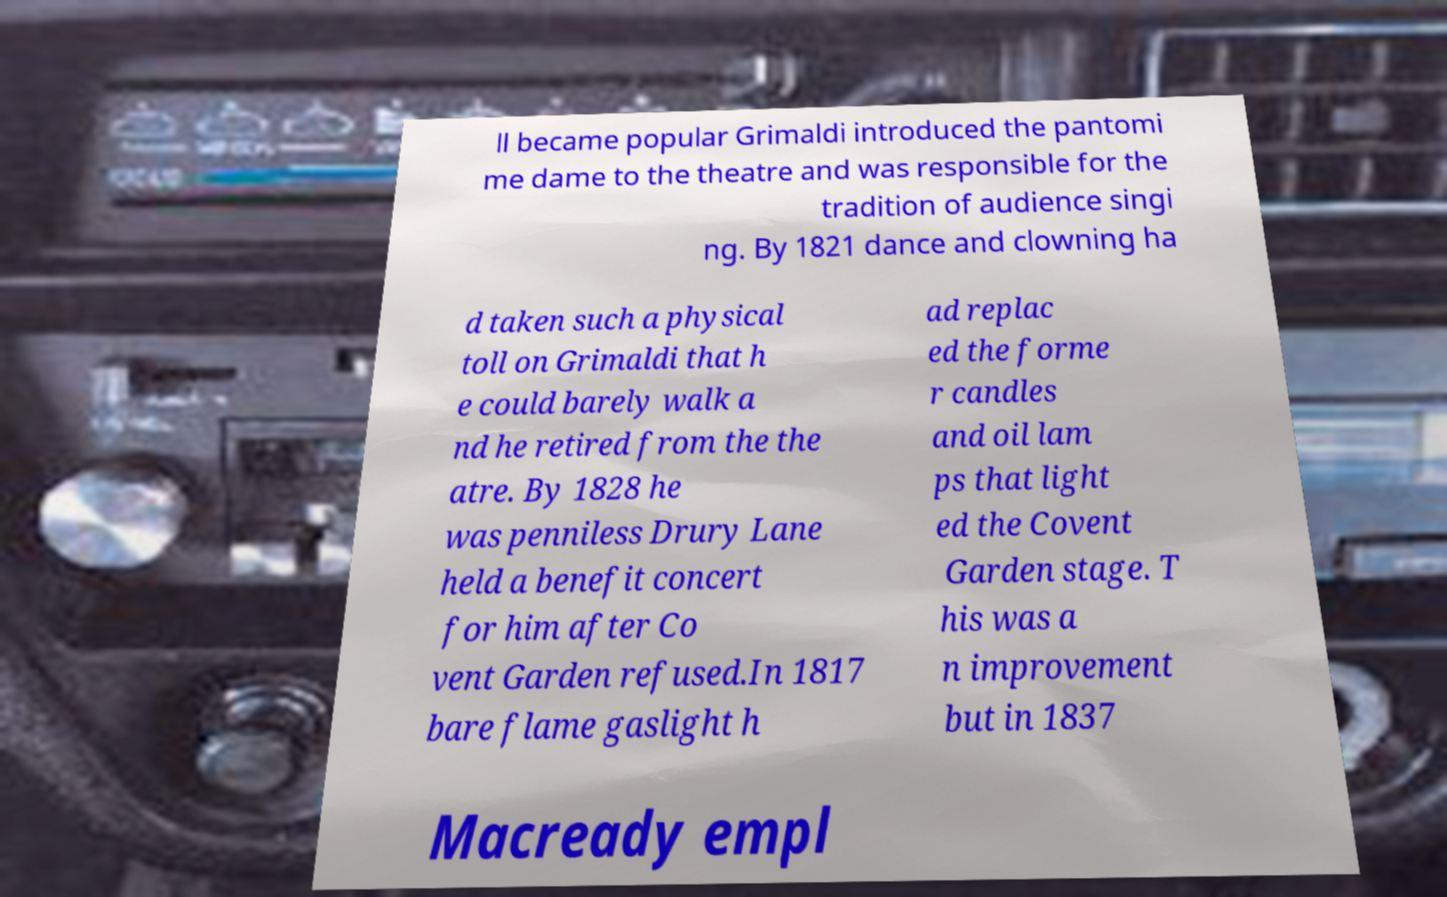Please read and relay the text visible in this image. What does it say? ll became popular Grimaldi introduced the pantomi me dame to the theatre and was responsible for the tradition of audience singi ng. By 1821 dance and clowning ha d taken such a physical toll on Grimaldi that h e could barely walk a nd he retired from the the atre. By 1828 he was penniless Drury Lane held a benefit concert for him after Co vent Garden refused.In 1817 bare flame gaslight h ad replac ed the forme r candles and oil lam ps that light ed the Covent Garden stage. T his was a n improvement but in 1837 Macready empl 